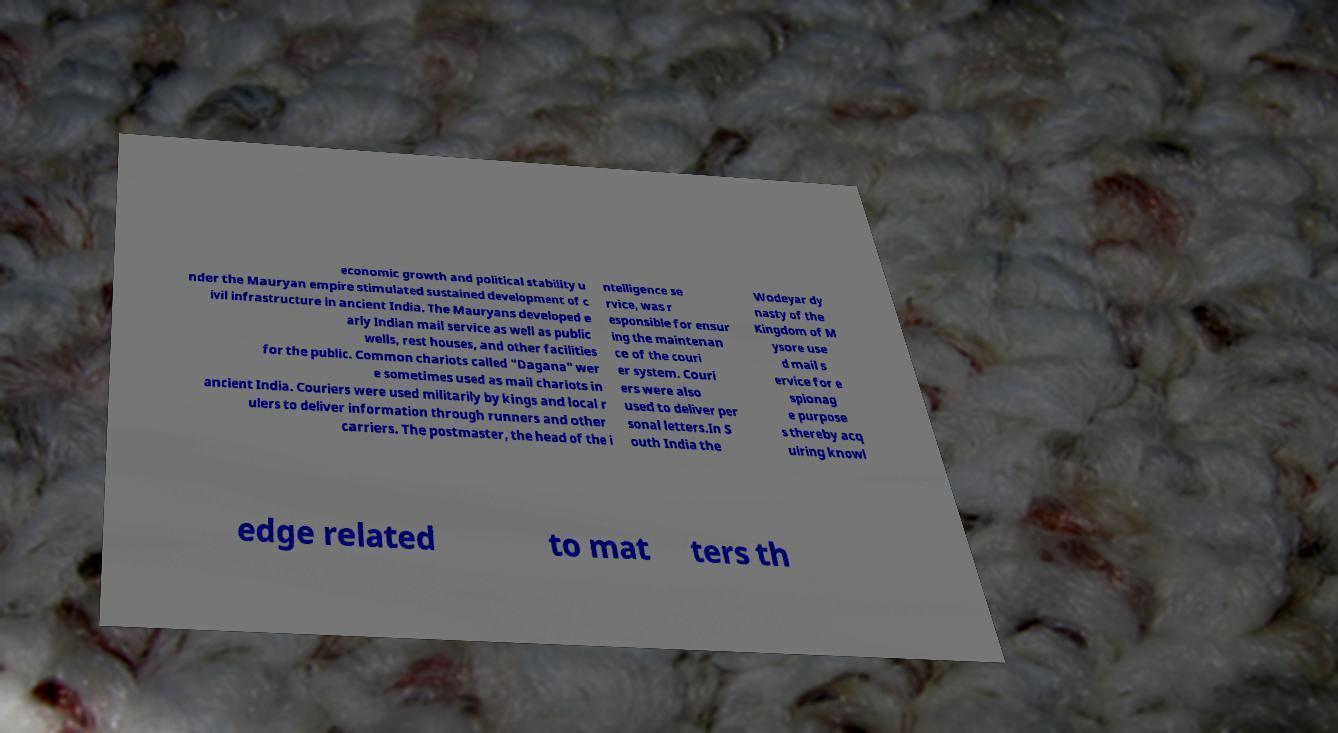Please identify and transcribe the text found in this image. economic growth and political stability u nder the Mauryan empire stimulated sustained development of c ivil infrastructure in ancient India. The Mauryans developed e arly Indian mail service as well as public wells, rest houses, and other facilities for the public. Common chariots called "Dagana" wer e sometimes used as mail chariots in ancient India. Couriers were used militarily by kings and local r ulers to deliver information through runners and other carriers. The postmaster, the head of the i ntelligence se rvice, was r esponsible for ensur ing the maintenan ce of the couri er system. Couri ers were also used to deliver per sonal letters.In S outh India the Wodeyar dy nasty of the Kingdom of M ysore use d mail s ervice for e spionag e purpose s thereby acq uiring knowl edge related to mat ters th 